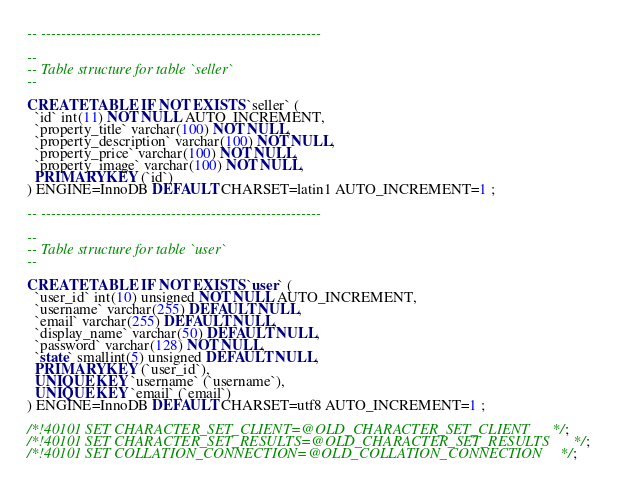<code> <loc_0><loc_0><loc_500><loc_500><_SQL_>
-- --------------------------------------------------------

--
-- Table structure for table `seller`
--

CREATE TABLE IF NOT EXISTS `seller` (
  `id` int(11) NOT NULL AUTO_INCREMENT,
  `property_title` varchar(100) NOT NULL,
  `property_description` varchar(100) NOT NULL,
  `property_price` varchar(100) NOT NULL,
  `property_image` varchar(100) NOT NULL,
  PRIMARY KEY (`id`)
) ENGINE=InnoDB DEFAULT CHARSET=latin1 AUTO_INCREMENT=1 ;

-- --------------------------------------------------------

--
-- Table structure for table `user`
--

CREATE TABLE IF NOT EXISTS `user` (
  `user_id` int(10) unsigned NOT NULL AUTO_INCREMENT,
  `username` varchar(255) DEFAULT NULL,
  `email` varchar(255) DEFAULT NULL,
  `display_name` varchar(50) DEFAULT NULL,
  `password` varchar(128) NOT NULL,
  `state` smallint(5) unsigned DEFAULT NULL,
  PRIMARY KEY (`user_id`),
  UNIQUE KEY `username` (`username`),
  UNIQUE KEY `email` (`email`)
) ENGINE=InnoDB DEFAULT CHARSET=utf8 AUTO_INCREMENT=1 ;

/*!40101 SET CHARACTER_SET_CLIENT=@OLD_CHARACTER_SET_CLIENT */;
/*!40101 SET CHARACTER_SET_RESULTS=@OLD_CHARACTER_SET_RESULTS */;
/*!40101 SET COLLATION_CONNECTION=@OLD_COLLATION_CONNECTION */;
</code> 